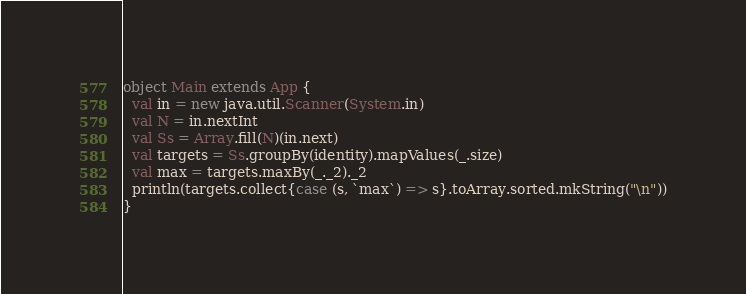<code> <loc_0><loc_0><loc_500><loc_500><_Scala_>object Main extends App {
  val in = new java.util.Scanner(System.in)
  val N = in.nextInt
  val Ss = Array.fill(N)(in.next)
  val targets = Ss.groupBy(identity).mapValues(_.size)
  val max = targets.maxBy(_._2)._2
  println(targets.collect{case (s, `max`) => s}.toArray.sorted.mkString("\n"))
}</code> 